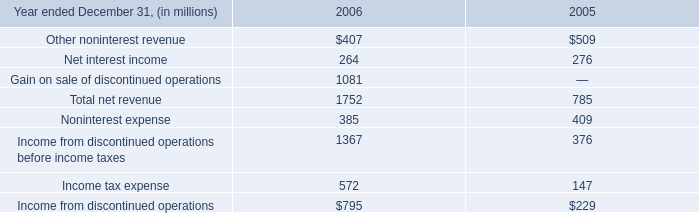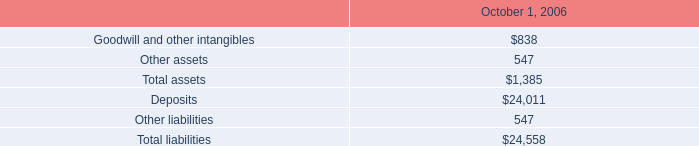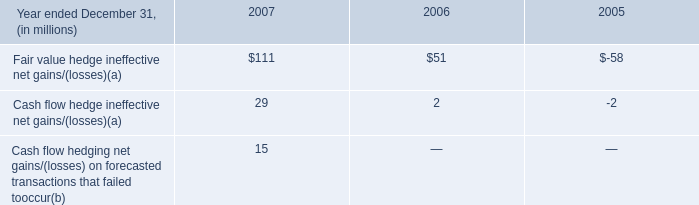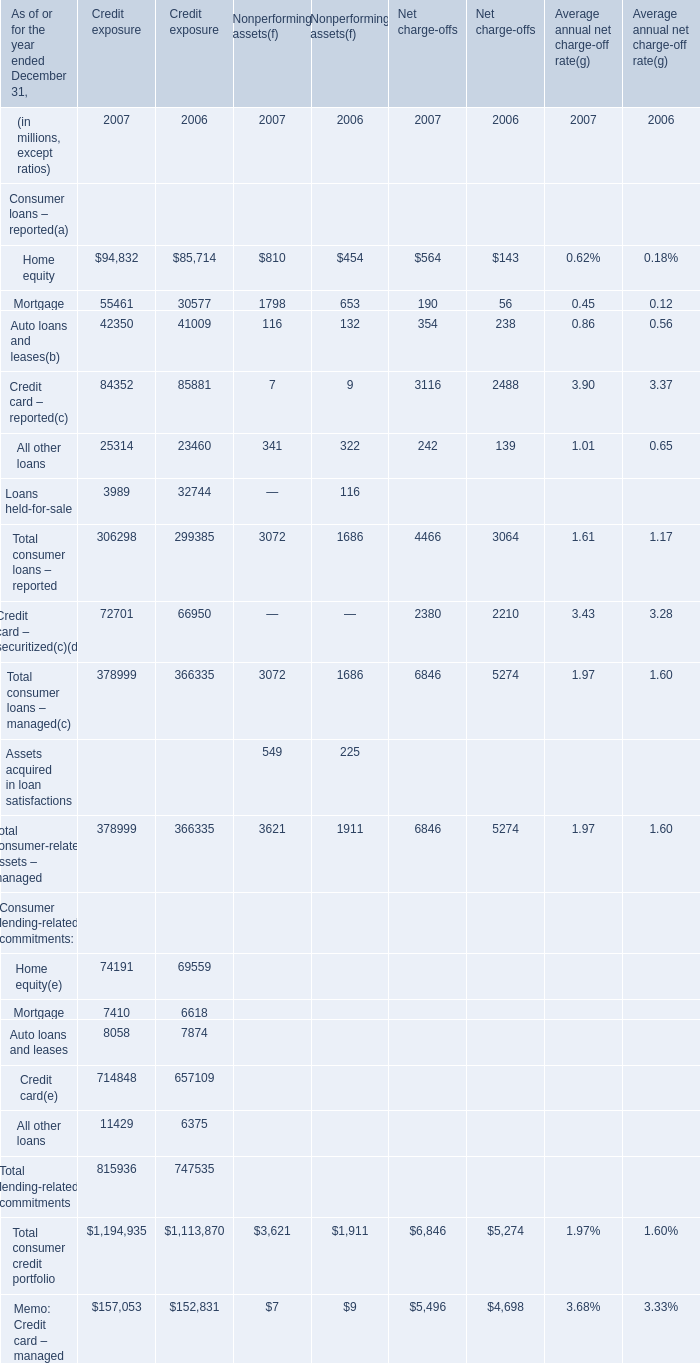What's the sum of the Home equity and Mortgage for Credit exposure in the years where Other assets is positive? (in million) 
Computations: (85714 + 30577)
Answer: 116291.0. 